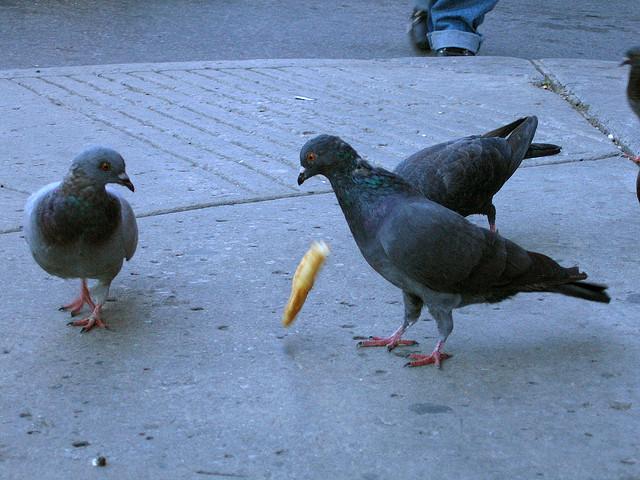Are these pigeons at the beach?
Give a very brief answer. No. What are these birds eating?
Be succinct. Bread. What type of birds are these?
Concise answer only. Pigeons. 